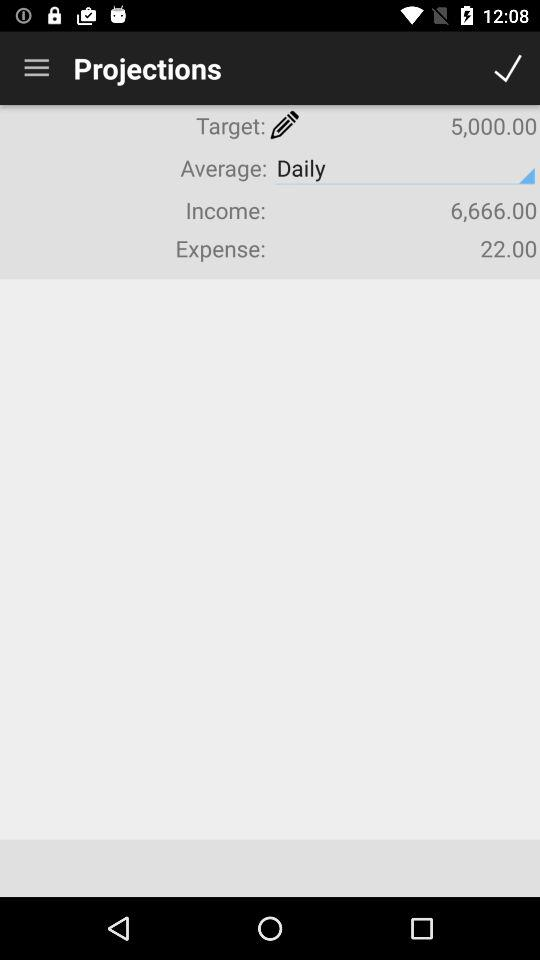How much is the income? The income is "6,666.00". 